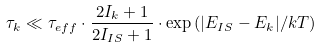<formula> <loc_0><loc_0><loc_500><loc_500>\tau _ { k } \ll \tau _ { e f f } \cdot \frac { 2 I _ { k } + 1 } { 2 I _ { I S } + 1 } \cdot \exp { ( { | E _ { I S } - E _ { k } | / k T } ) }</formula> 